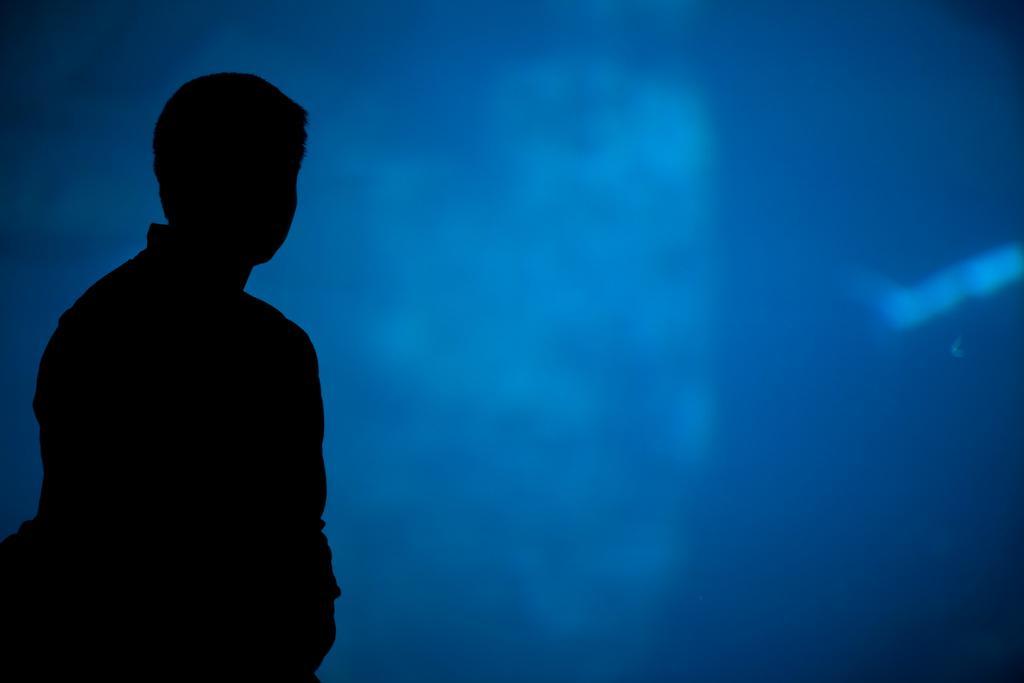Can you describe this image briefly? On the left side of the image there is a person and the background of the image is blue. 